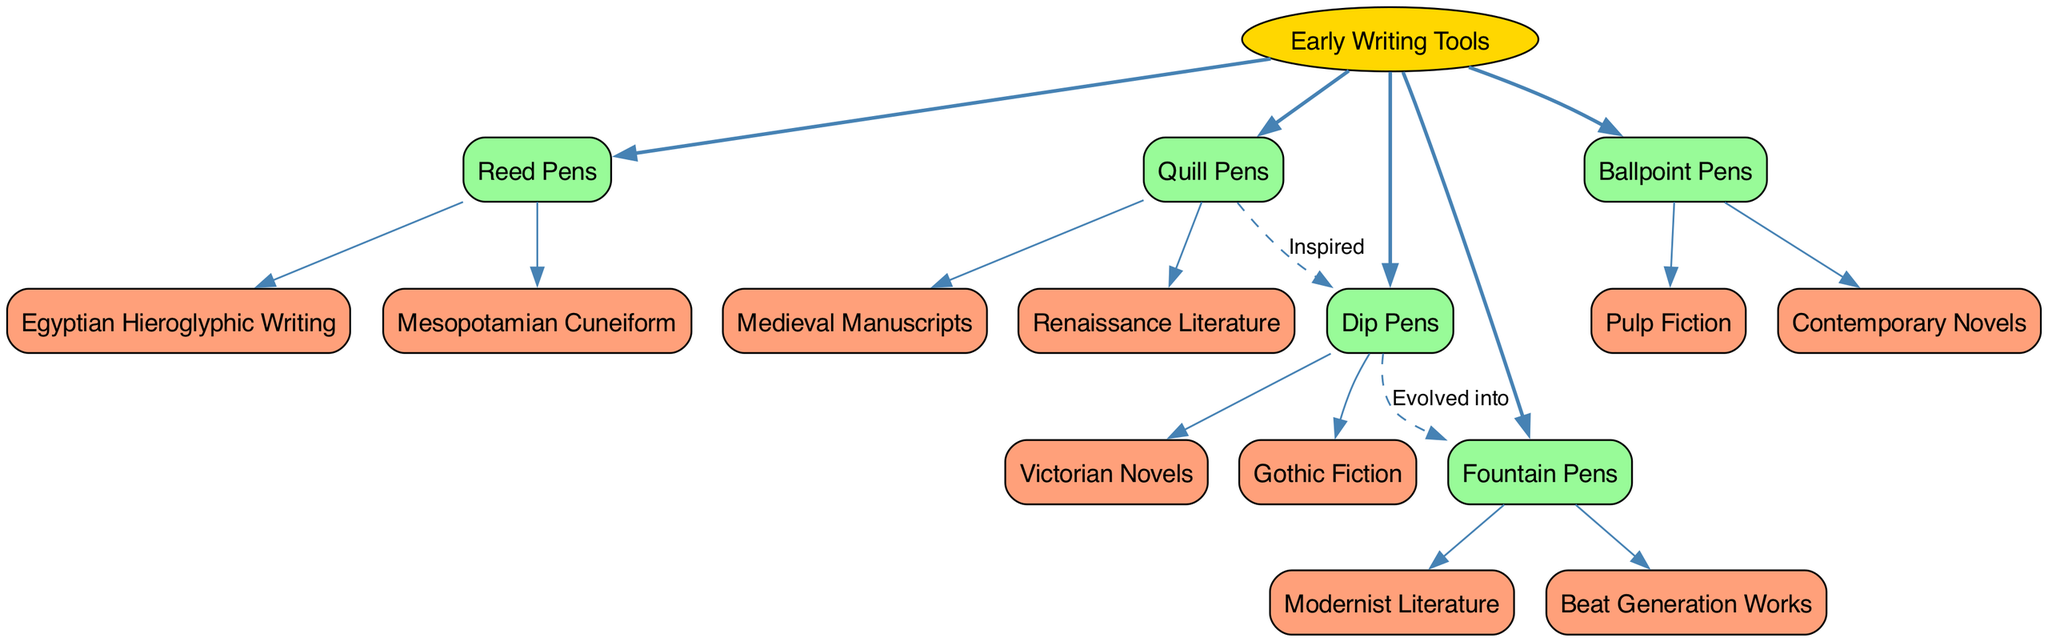What is the root of the evolutionary tree? The root of the evolutionary tree is labeled as "Early Writing Tools," and it is the starting point for all other branches in the diagram.
Answer: Early Writing Tools How many branches are there in the diagram? The diagram contains five branches originating from the root "Early Writing Tools," representing different pen technologies.
Answer: 5 Which pen technology evolved into Fountain Pens? The diagram indicates that Dip Pens evolved into Fountain Pens, connecting these two technologies with a dashed line labeled "Evolved into."
Answer: Dip Pens What is a descendant of Reed Pens? The descendants of Reed Pens, as shown in the diagram, include "Egyptian Hieroglyphic Writing" and "Mesopotamian Cuneiform." Selecting any of these descendants is valid, but focusing on just one, "Egyptian Hieroglyphic Writing" can be listed.
Answer: Egyptian Hieroglyphic Writing Which two literary movements are connected to Ballpoint Pens? The descendants associated with Ballpoint Pens in the diagram are "Pulp Fiction" and "Contemporary Novels," showcasing the literary works that used this technology. In this case, both or either can be valid answers, but specifying them both shows thorough knowledge.
Answer: Pulp Fiction, Contemporary Novels Which writing tool inspired Dip Pens? The evolution diagram shows that Quill Pens inspired Dip Pens, establishing a direct connection marked with the label "Inspired."
Answer: Quill Pens What color are the branches in the diagram? In the diagram, the branches representing various pen technologies are filled with a soft green color, indicated by the fillcolor attribute of '#98FB98'.
Answer: Soft green How many descendants does Quill Pens have? Quill Pens has two descendants listed: "Medieval Manuscripts" and "Renaissance Literature," representing the historical literary outputs associated with this technology.
Answer: 2 Which writing tool is connected to the concepts of Modernist Literature? The diagram indicates that Fountain Pens are directly associated with "Modernist Literature," showcasing how this writing tool relates to specific literary movements.
Answer: Fountain Pens 